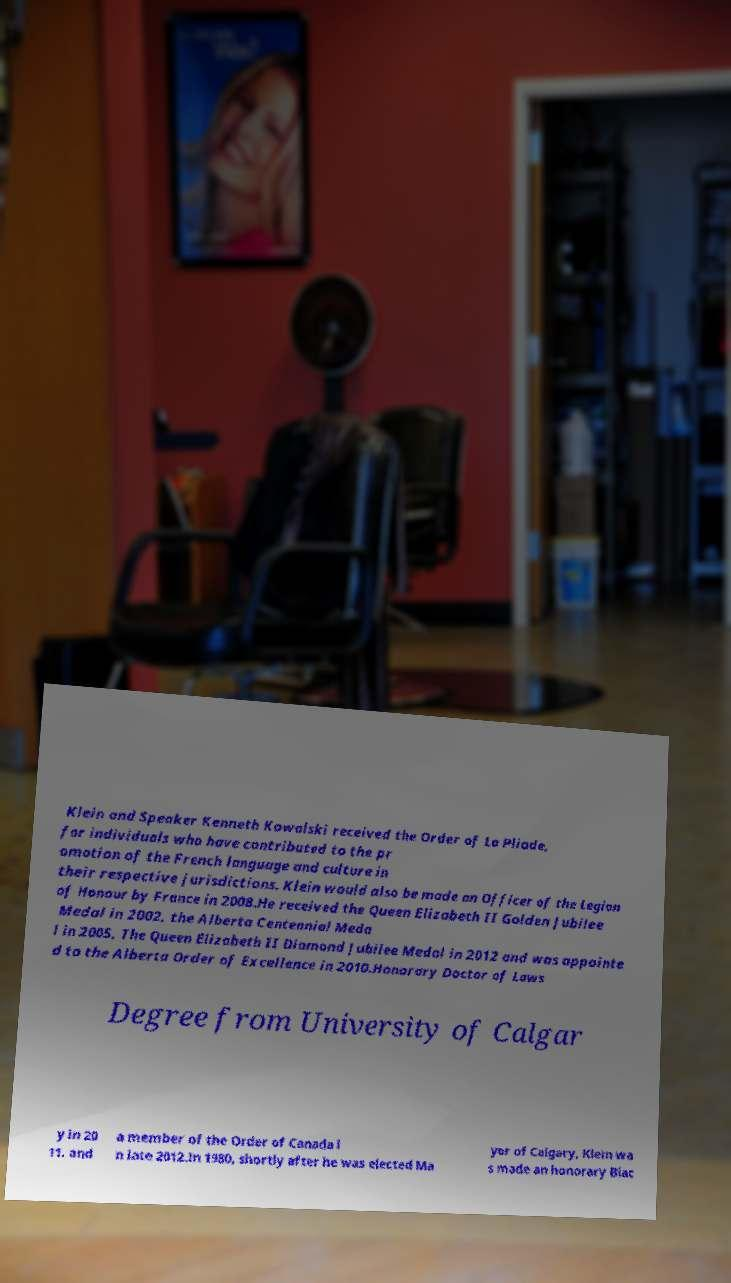I need the written content from this picture converted into text. Can you do that? Klein and Speaker Kenneth Kowalski received the Order of La Pliade, for individuals who have contributed to the pr omotion of the French language and culture in their respective jurisdictions. Klein would also be made an Officer of the Legion of Honour by France in 2008.He received the Queen Elizabeth II Golden Jubilee Medal in 2002, the Alberta Centennial Meda l in 2005, The Queen Elizabeth II Diamond Jubilee Medal in 2012 and was appointe d to the Alberta Order of Excellence in 2010.Honorary Doctor of Laws Degree from University of Calgar y in 20 11. and a member of the Order of Canada i n late 2012.In 1980, shortly after he was elected Ma yor of Calgary, Klein wa s made an honorary Blac 